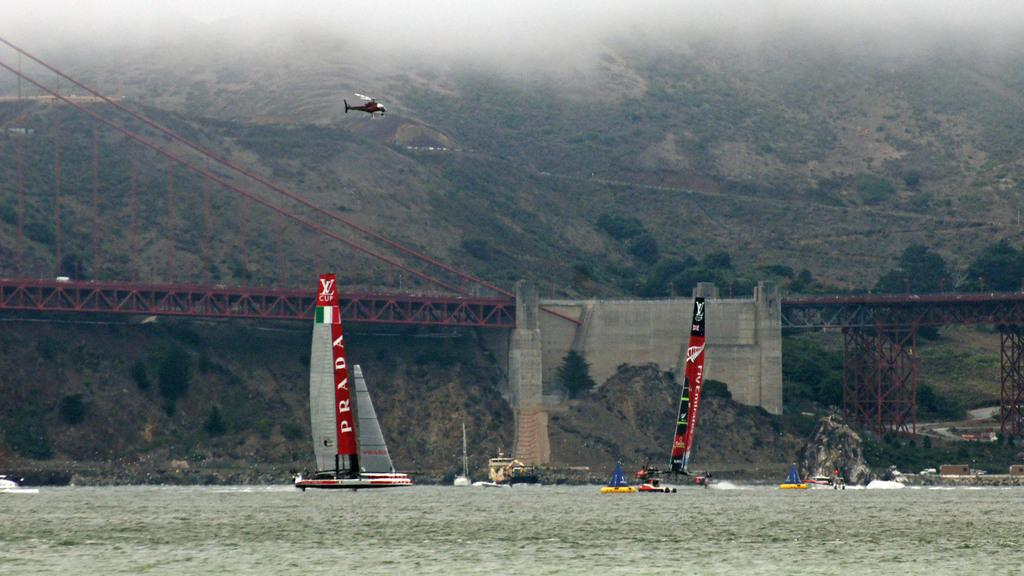What is the main subject of the image? The main subject of the image is a group of boats. Where are the boats located? The boats are on water. What can be seen in the background of the image? There is an airplane, trees, and a bridge in the background of the image. What type of mailbox can be seen near the boats in the image? There is no mailbox present in the image. What company operates the boats in the image? The image does not provide information about the company operating the boats. 